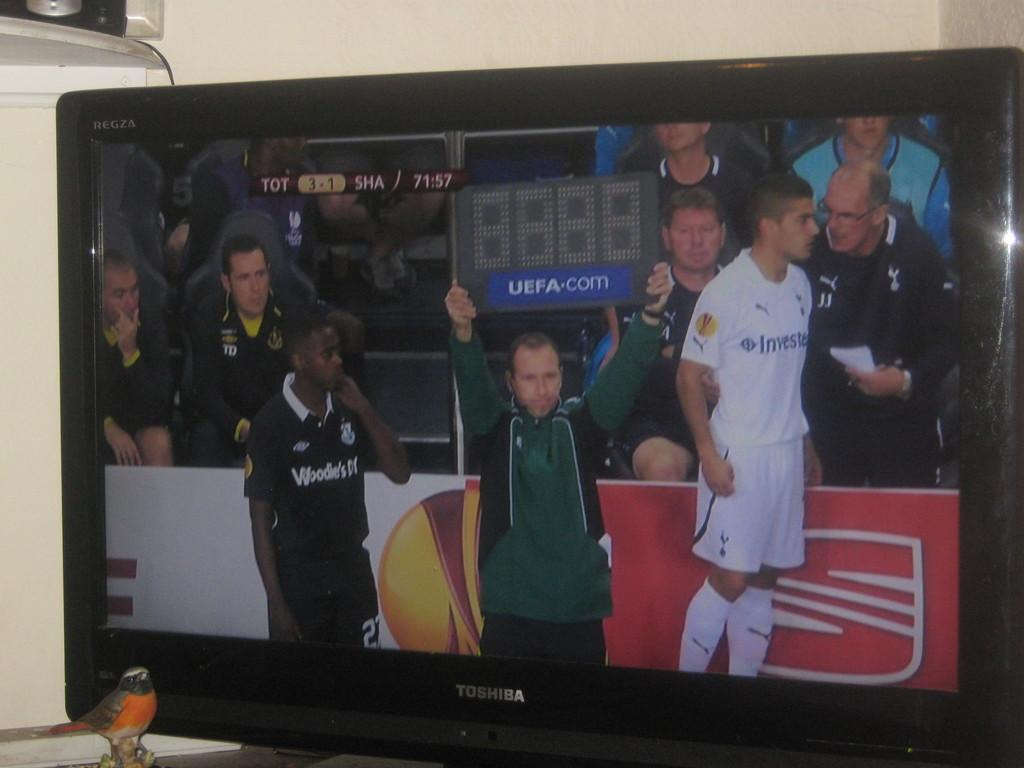<image>
Share a concise interpretation of the image provided. UEFA.com is on the board held up by the man in green. 